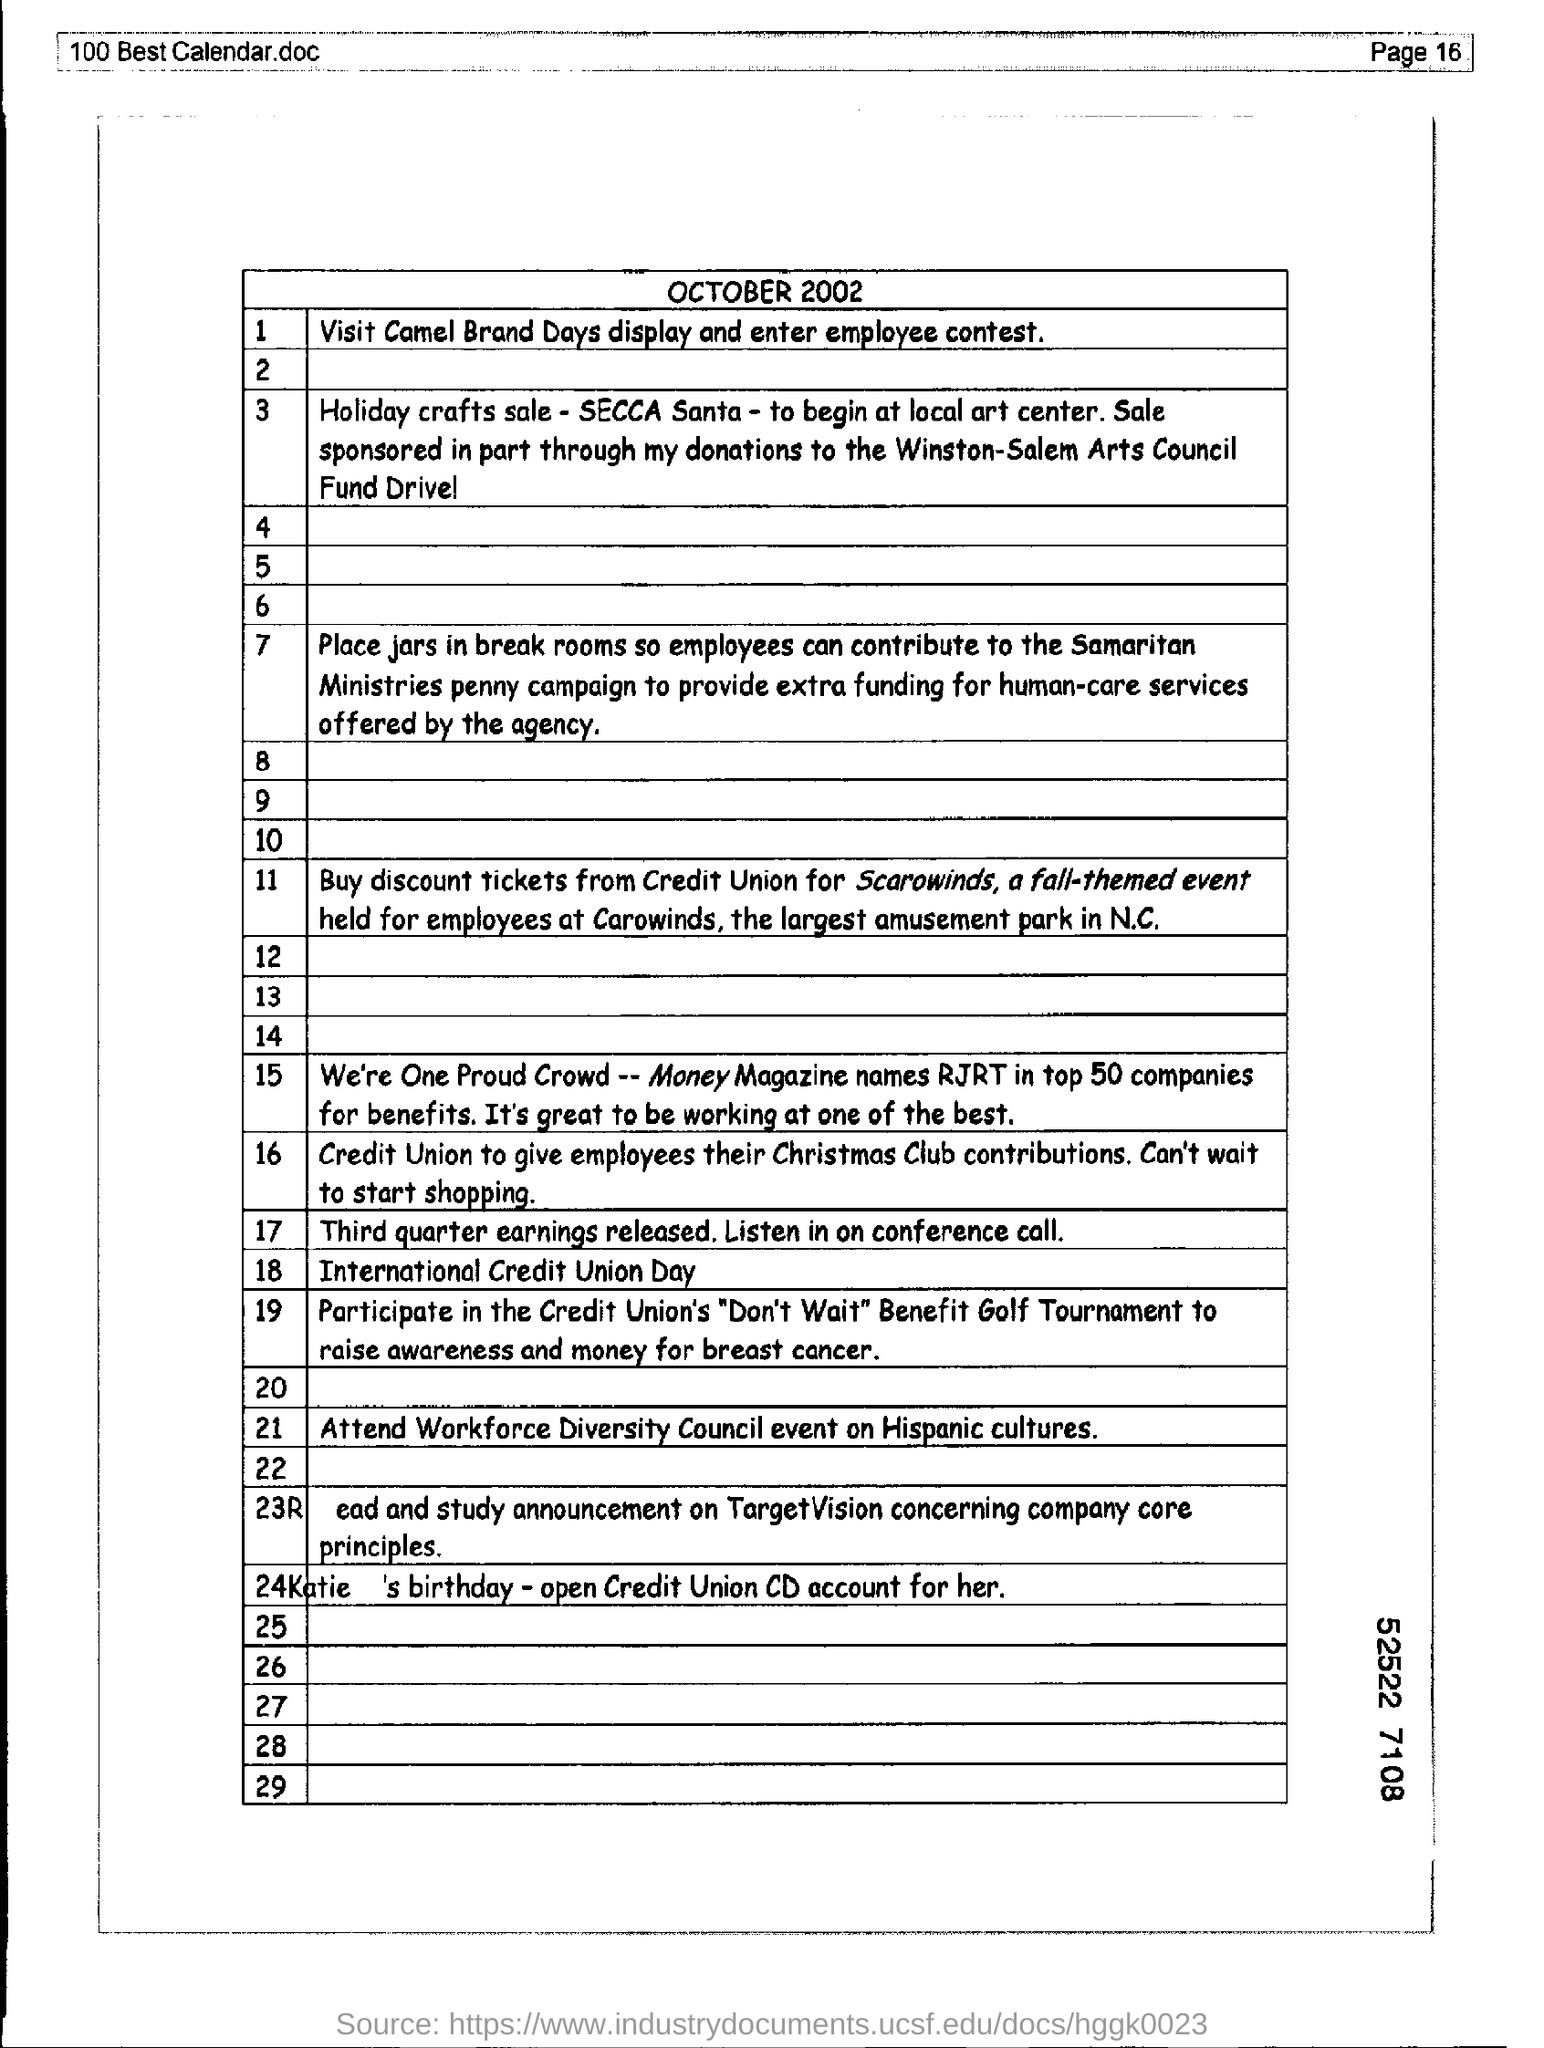Highlight a few significant elements in this photo. The page number of the document is 16. 